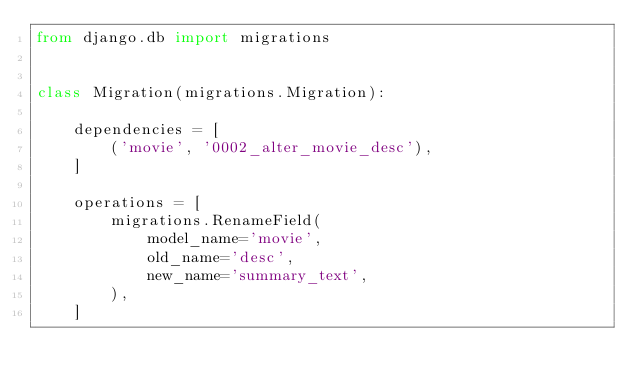<code> <loc_0><loc_0><loc_500><loc_500><_Python_>from django.db import migrations


class Migration(migrations.Migration):

    dependencies = [
        ('movie', '0002_alter_movie_desc'),
    ]

    operations = [
        migrations.RenameField(
            model_name='movie',
            old_name='desc',
            new_name='summary_text',
        ),
    ]
</code> 